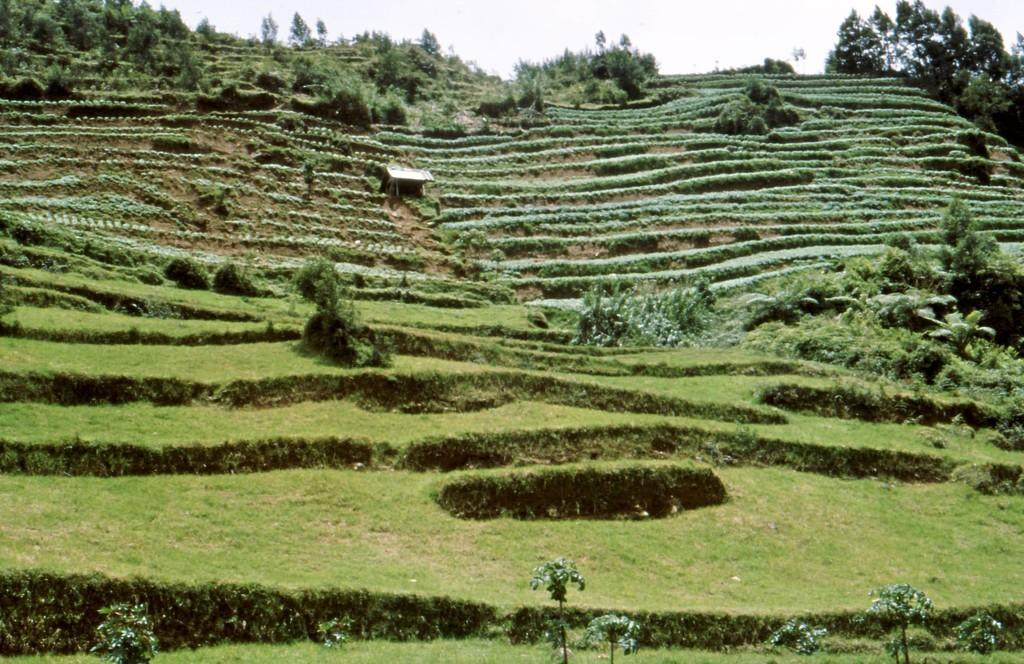What type of vegetation is present on the ground in the image? There is grass and plants on the ground in the image. What can be seen in the background of the image? There are trees and the sky visible in the background of the image. Is there a playground visible in the image? There is no playground present in the image. What type of destruction can be seen in the image? There is no destruction present in the image; it features grass, plants, trees, and the sky. 